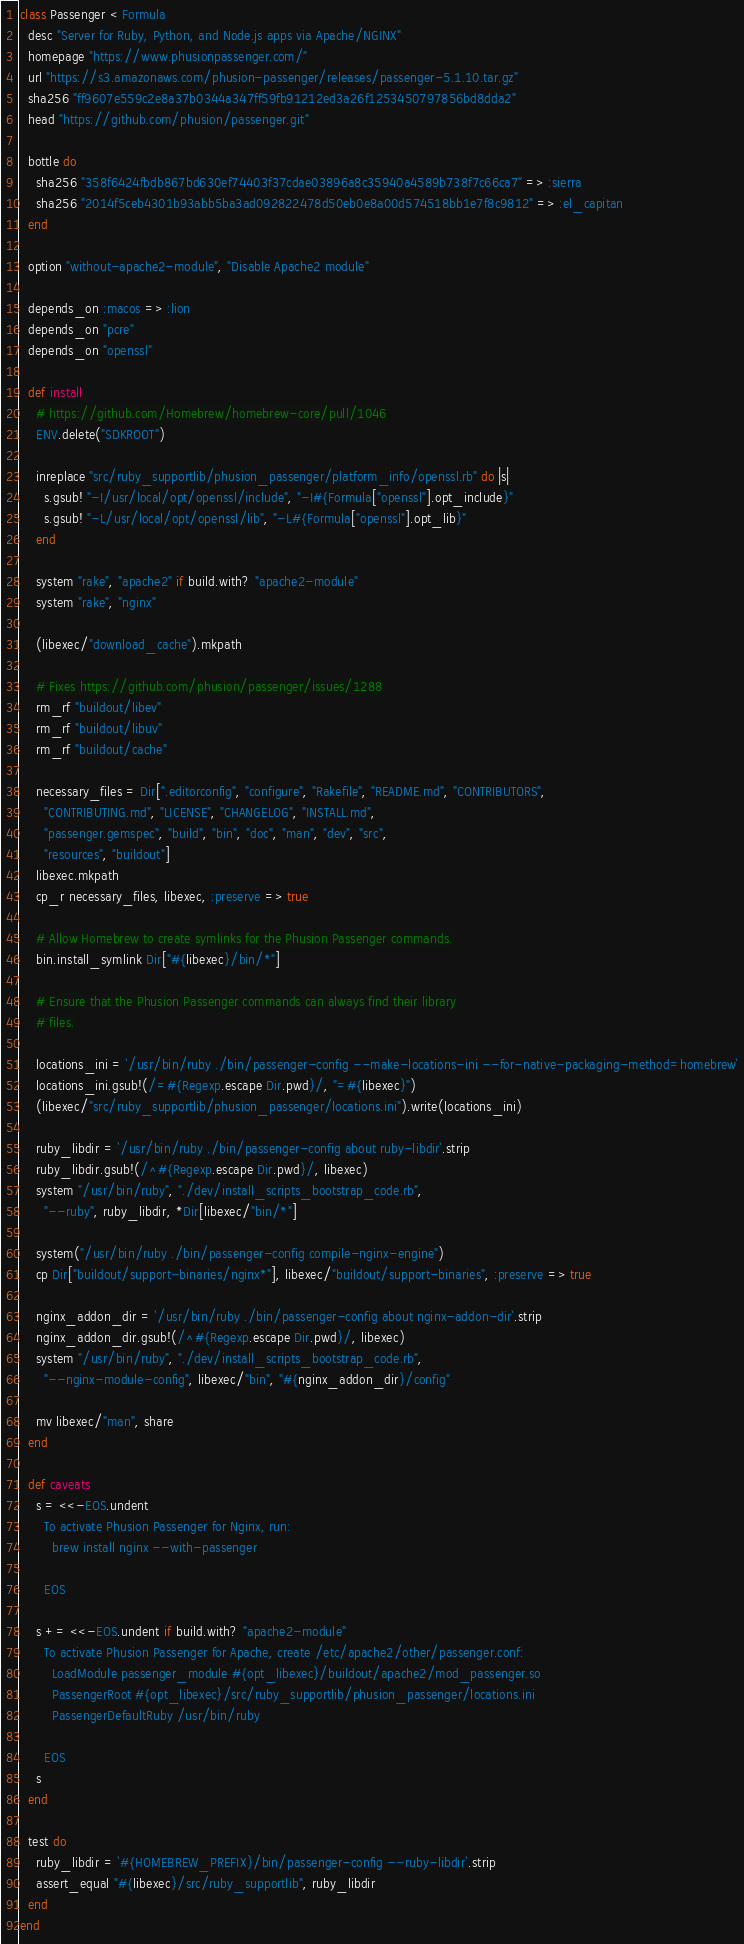Convert code to text. <code><loc_0><loc_0><loc_500><loc_500><_Ruby_>class Passenger < Formula
  desc "Server for Ruby, Python, and Node.js apps via Apache/NGINX"
  homepage "https://www.phusionpassenger.com/"
  url "https://s3.amazonaws.com/phusion-passenger/releases/passenger-5.1.10.tar.gz"
  sha256 "ff9607e559c2e8a37b0344a347ff59fb91212ed3a26f1253450797856bd8dda2"
  head "https://github.com/phusion/passenger.git"

  bottle do
    sha256 "358f6424fbdb867bd630ef74403f37cdae03896a8c35940a4589b738f7c66ca7" => :sierra
    sha256 "2014f5ceb4301b93abb5ba3ad092822478d50eb0e8a00d574518bb1e7f8c9812" => :el_capitan
  end

  option "without-apache2-module", "Disable Apache2 module"

  depends_on :macos => :lion
  depends_on "pcre"
  depends_on "openssl"

  def install
    # https://github.com/Homebrew/homebrew-core/pull/1046
    ENV.delete("SDKROOT")

    inreplace "src/ruby_supportlib/phusion_passenger/platform_info/openssl.rb" do |s|
      s.gsub! "-I/usr/local/opt/openssl/include", "-I#{Formula["openssl"].opt_include}"
      s.gsub! "-L/usr/local/opt/openssl/lib", "-L#{Formula["openssl"].opt_lib}"
    end

    system "rake", "apache2" if build.with? "apache2-module"
    system "rake", "nginx"

    (libexec/"download_cache").mkpath

    # Fixes https://github.com/phusion/passenger/issues/1288
    rm_rf "buildout/libev"
    rm_rf "buildout/libuv"
    rm_rf "buildout/cache"

    necessary_files = Dir[".editorconfig", "configure", "Rakefile", "README.md", "CONTRIBUTORS",
      "CONTRIBUTING.md", "LICENSE", "CHANGELOG", "INSTALL.md",
      "passenger.gemspec", "build", "bin", "doc", "man", "dev", "src",
      "resources", "buildout"]
    libexec.mkpath
    cp_r necessary_files, libexec, :preserve => true

    # Allow Homebrew to create symlinks for the Phusion Passenger commands.
    bin.install_symlink Dir["#{libexec}/bin/*"]

    # Ensure that the Phusion Passenger commands can always find their library
    # files.

    locations_ini = `/usr/bin/ruby ./bin/passenger-config --make-locations-ini --for-native-packaging-method=homebrew`
    locations_ini.gsub!(/=#{Regexp.escape Dir.pwd}/, "=#{libexec}")
    (libexec/"src/ruby_supportlib/phusion_passenger/locations.ini").write(locations_ini)

    ruby_libdir = `/usr/bin/ruby ./bin/passenger-config about ruby-libdir`.strip
    ruby_libdir.gsub!(/^#{Regexp.escape Dir.pwd}/, libexec)
    system "/usr/bin/ruby", "./dev/install_scripts_bootstrap_code.rb",
      "--ruby", ruby_libdir, *Dir[libexec/"bin/*"]

    system("/usr/bin/ruby ./bin/passenger-config compile-nginx-engine")
    cp Dir["buildout/support-binaries/nginx*"], libexec/"buildout/support-binaries", :preserve => true

    nginx_addon_dir = `/usr/bin/ruby ./bin/passenger-config about nginx-addon-dir`.strip
    nginx_addon_dir.gsub!(/^#{Regexp.escape Dir.pwd}/, libexec)
    system "/usr/bin/ruby", "./dev/install_scripts_bootstrap_code.rb",
      "--nginx-module-config", libexec/"bin", "#{nginx_addon_dir}/config"

    mv libexec/"man", share
  end

  def caveats
    s = <<-EOS.undent
      To activate Phusion Passenger for Nginx, run:
        brew install nginx --with-passenger

      EOS

    s += <<-EOS.undent if build.with? "apache2-module"
      To activate Phusion Passenger for Apache, create /etc/apache2/other/passenger.conf:
        LoadModule passenger_module #{opt_libexec}/buildout/apache2/mod_passenger.so
        PassengerRoot #{opt_libexec}/src/ruby_supportlib/phusion_passenger/locations.ini
        PassengerDefaultRuby /usr/bin/ruby

      EOS
    s
  end

  test do
    ruby_libdir = `#{HOMEBREW_PREFIX}/bin/passenger-config --ruby-libdir`.strip
    assert_equal "#{libexec}/src/ruby_supportlib", ruby_libdir
  end
end
</code> 